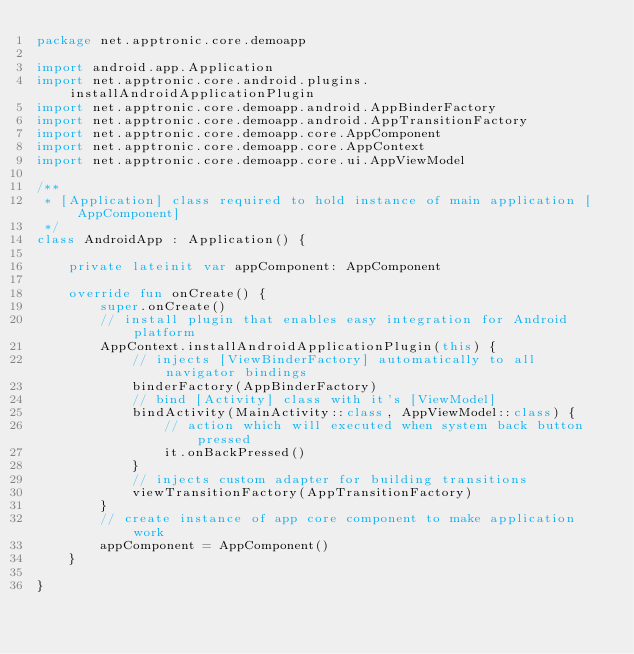<code> <loc_0><loc_0><loc_500><loc_500><_Kotlin_>package net.apptronic.core.demoapp

import android.app.Application
import net.apptronic.core.android.plugins.installAndroidApplicationPlugin
import net.apptronic.core.demoapp.android.AppBinderFactory
import net.apptronic.core.demoapp.android.AppTransitionFactory
import net.apptronic.core.demoapp.core.AppComponent
import net.apptronic.core.demoapp.core.AppContext
import net.apptronic.core.demoapp.core.ui.AppViewModel

/**
 * [Application] class required to hold instance of main application [AppComponent]
 */
class AndroidApp : Application() {

    private lateinit var appComponent: AppComponent

    override fun onCreate() {
        super.onCreate()
        // install plugin that enables easy integration for Android platform
        AppContext.installAndroidApplicationPlugin(this) {
            // injects [ViewBinderFactory] automatically to all navigator bindings
            binderFactory(AppBinderFactory)
            // bind [Activity] class with it's [ViewModel]
            bindActivity(MainActivity::class, AppViewModel::class) {
                // action which will executed when system back button pressed
                it.onBackPressed()
            }
            // injects custom adapter for building transitions
            viewTransitionFactory(AppTransitionFactory)
        }
        // create instance of app core component to make application work
        appComponent = AppComponent()
    }

}</code> 